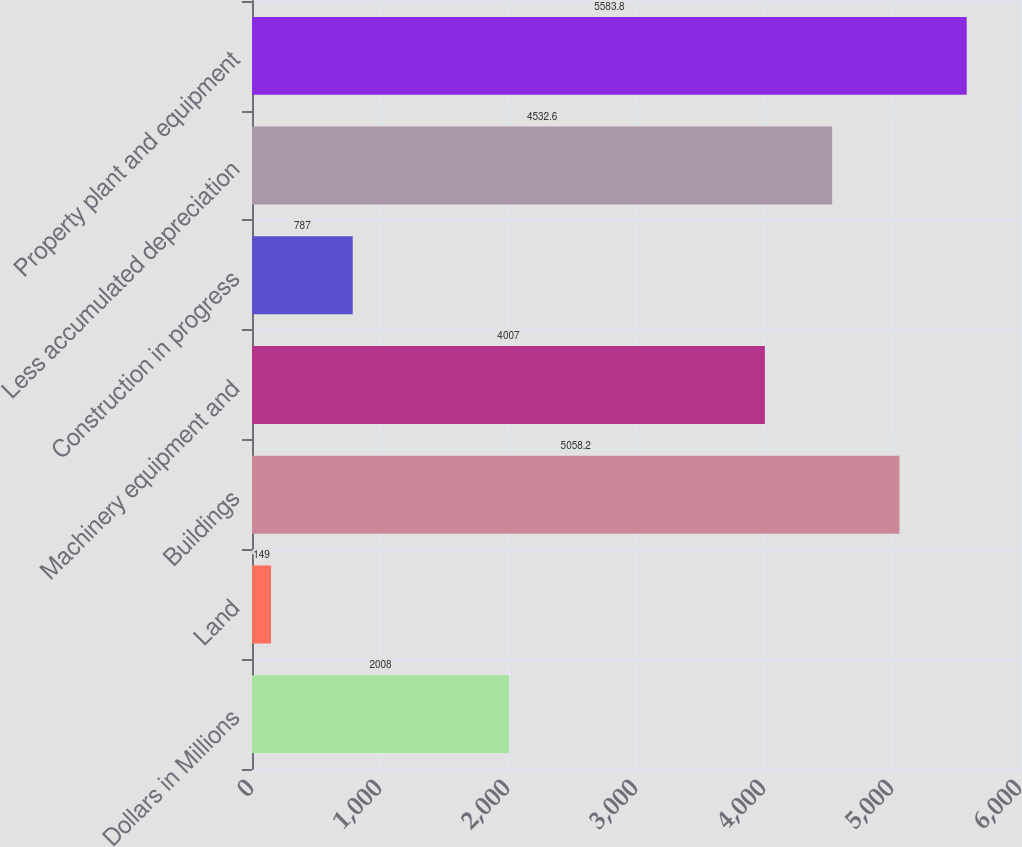<chart> <loc_0><loc_0><loc_500><loc_500><bar_chart><fcel>Dollars in Millions<fcel>Land<fcel>Buildings<fcel>Machinery equipment and<fcel>Construction in progress<fcel>Less accumulated depreciation<fcel>Property plant and equipment<nl><fcel>2008<fcel>149<fcel>5058.2<fcel>4007<fcel>787<fcel>4532.6<fcel>5583.8<nl></chart> 